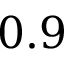Convert formula to latex. <formula><loc_0><loc_0><loc_500><loc_500>0 . 9</formula> 